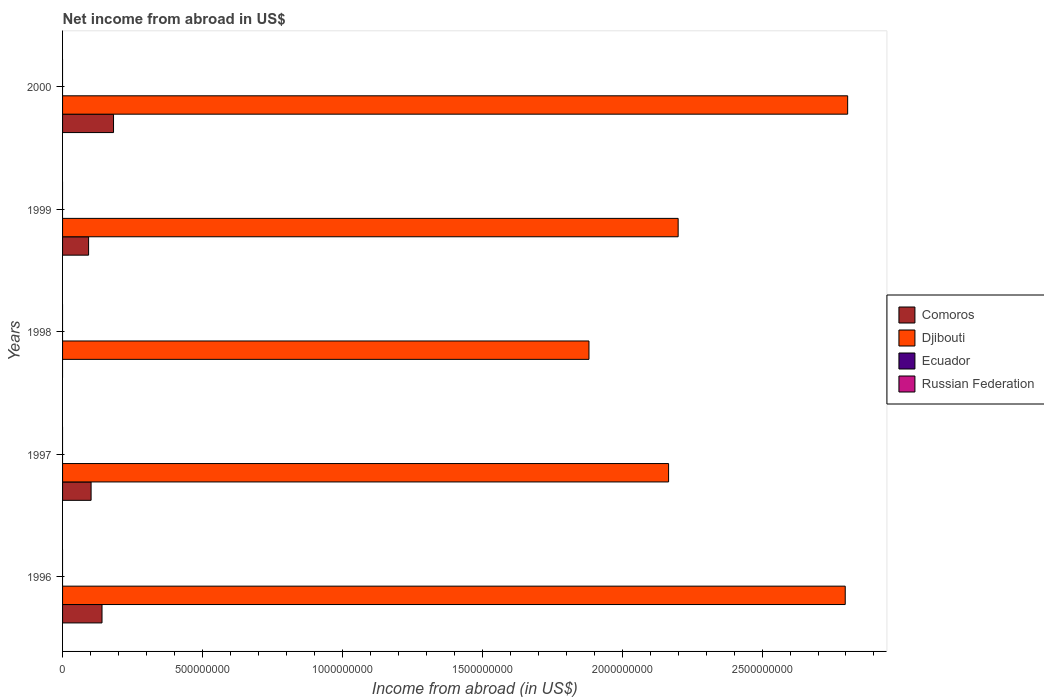How many different coloured bars are there?
Give a very brief answer. 2. Are the number of bars per tick equal to the number of legend labels?
Provide a short and direct response. No. Are the number of bars on each tick of the Y-axis equal?
Your response must be concise. No. How many bars are there on the 5th tick from the top?
Your response must be concise. 2. How many bars are there on the 4th tick from the bottom?
Your answer should be compact. 2. What is the label of the 1st group of bars from the top?
Offer a very short reply. 2000. Across all years, what is the maximum net income from abroad in Djibouti?
Your answer should be very brief. 2.81e+09. Across all years, what is the minimum net income from abroad in Djibouti?
Ensure brevity in your answer.  1.88e+09. In which year was the net income from abroad in Comoros maximum?
Give a very brief answer. 2000. What is the total net income from abroad in Ecuador in the graph?
Ensure brevity in your answer.  0. What is the difference between the net income from abroad in Comoros in 1997 and that in 2000?
Offer a very short reply. -8.02e+07. What is the difference between the net income from abroad in Djibouti in 1996 and the net income from abroad in Ecuador in 2000?
Offer a very short reply. 2.80e+09. What is the average net income from abroad in Comoros per year?
Offer a very short reply. 1.04e+08. In the year 1996, what is the difference between the net income from abroad in Djibouti and net income from abroad in Comoros?
Make the answer very short. 2.66e+09. In how many years, is the net income from abroad in Ecuador greater than 900000000 US$?
Your answer should be very brief. 0. What is the ratio of the net income from abroad in Comoros in 1997 to that in 1999?
Make the answer very short. 1.1. Is the net income from abroad in Comoros in 1997 less than that in 1999?
Provide a short and direct response. No. What is the difference between the highest and the second highest net income from abroad in Comoros?
Provide a succinct answer. 4.12e+07. What is the difference between the highest and the lowest net income from abroad in Comoros?
Ensure brevity in your answer.  1.82e+08. Is it the case that in every year, the sum of the net income from abroad in Russian Federation and net income from abroad in Ecuador is greater than the net income from abroad in Comoros?
Provide a succinct answer. No. How many years are there in the graph?
Give a very brief answer. 5. What is the difference between two consecutive major ticks on the X-axis?
Your answer should be compact. 5.00e+08. Does the graph contain grids?
Your answer should be very brief. No. How many legend labels are there?
Provide a succinct answer. 4. What is the title of the graph?
Your answer should be very brief. Net income from abroad in US$. Does "Albania" appear as one of the legend labels in the graph?
Give a very brief answer. No. What is the label or title of the X-axis?
Provide a short and direct response. Income from abroad (in US$). What is the label or title of the Y-axis?
Your answer should be very brief. Years. What is the Income from abroad (in US$) in Comoros in 1996?
Your answer should be compact. 1.41e+08. What is the Income from abroad (in US$) of Djibouti in 1996?
Give a very brief answer. 2.80e+09. What is the Income from abroad (in US$) of Comoros in 1997?
Provide a succinct answer. 1.02e+08. What is the Income from abroad (in US$) in Djibouti in 1997?
Your answer should be very brief. 2.17e+09. What is the Income from abroad (in US$) of Comoros in 1998?
Offer a very short reply. 0. What is the Income from abroad (in US$) of Djibouti in 1998?
Your answer should be compact. 1.88e+09. What is the Income from abroad (in US$) of Ecuador in 1998?
Provide a short and direct response. 0. What is the Income from abroad (in US$) in Russian Federation in 1998?
Offer a terse response. 0. What is the Income from abroad (in US$) in Comoros in 1999?
Your answer should be compact. 9.30e+07. What is the Income from abroad (in US$) of Djibouti in 1999?
Provide a succinct answer. 2.20e+09. What is the Income from abroad (in US$) in Ecuador in 1999?
Give a very brief answer. 0. What is the Income from abroad (in US$) of Russian Federation in 1999?
Offer a very short reply. 0. What is the Income from abroad (in US$) in Comoros in 2000?
Your response must be concise. 1.82e+08. What is the Income from abroad (in US$) of Djibouti in 2000?
Offer a very short reply. 2.81e+09. What is the Income from abroad (in US$) of Russian Federation in 2000?
Offer a very short reply. 0. Across all years, what is the maximum Income from abroad (in US$) of Comoros?
Give a very brief answer. 1.82e+08. Across all years, what is the maximum Income from abroad (in US$) in Djibouti?
Provide a short and direct response. 2.81e+09. Across all years, what is the minimum Income from abroad (in US$) of Comoros?
Offer a very short reply. 0. Across all years, what is the minimum Income from abroad (in US$) of Djibouti?
Keep it short and to the point. 1.88e+09. What is the total Income from abroad (in US$) of Comoros in the graph?
Provide a succinct answer. 5.18e+08. What is the total Income from abroad (in US$) of Djibouti in the graph?
Provide a succinct answer. 1.19e+1. What is the total Income from abroad (in US$) of Ecuador in the graph?
Offer a terse response. 0. What is the total Income from abroad (in US$) of Russian Federation in the graph?
Offer a terse response. 0. What is the difference between the Income from abroad (in US$) of Comoros in 1996 and that in 1997?
Make the answer very short. 3.90e+07. What is the difference between the Income from abroad (in US$) in Djibouti in 1996 and that in 1997?
Keep it short and to the point. 6.31e+08. What is the difference between the Income from abroad (in US$) of Djibouti in 1996 and that in 1998?
Offer a very short reply. 9.16e+08. What is the difference between the Income from abroad (in US$) in Comoros in 1996 and that in 1999?
Give a very brief answer. 4.80e+07. What is the difference between the Income from abroad (in US$) of Djibouti in 1996 and that in 1999?
Ensure brevity in your answer.  5.97e+08. What is the difference between the Income from abroad (in US$) in Comoros in 1996 and that in 2000?
Keep it short and to the point. -4.12e+07. What is the difference between the Income from abroad (in US$) of Djibouti in 1996 and that in 2000?
Ensure brevity in your answer.  -8.66e+06. What is the difference between the Income from abroad (in US$) of Djibouti in 1997 and that in 1998?
Your answer should be very brief. 2.85e+08. What is the difference between the Income from abroad (in US$) of Comoros in 1997 and that in 1999?
Offer a terse response. 8.99e+06. What is the difference between the Income from abroad (in US$) of Djibouti in 1997 and that in 1999?
Keep it short and to the point. -3.42e+07. What is the difference between the Income from abroad (in US$) of Comoros in 1997 and that in 2000?
Your answer should be compact. -8.02e+07. What is the difference between the Income from abroad (in US$) of Djibouti in 1997 and that in 2000?
Ensure brevity in your answer.  -6.40e+08. What is the difference between the Income from abroad (in US$) in Djibouti in 1998 and that in 1999?
Make the answer very short. -3.19e+08. What is the difference between the Income from abroad (in US$) of Djibouti in 1998 and that in 2000?
Your answer should be very brief. -9.25e+08. What is the difference between the Income from abroad (in US$) of Comoros in 1999 and that in 2000?
Provide a short and direct response. -8.92e+07. What is the difference between the Income from abroad (in US$) in Djibouti in 1999 and that in 2000?
Provide a short and direct response. -6.06e+08. What is the difference between the Income from abroad (in US$) of Comoros in 1996 and the Income from abroad (in US$) of Djibouti in 1997?
Keep it short and to the point. -2.03e+09. What is the difference between the Income from abroad (in US$) in Comoros in 1996 and the Income from abroad (in US$) in Djibouti in 1998?
Offer a terse response. -1.74e+09. What is the difference between the Income from abroad (in US$) of Comoros in 1996 and the Income from abroad (in US$) of Djibouti in 1999?
Your answer should be compact. -2.06e+09. What is the difference between the Income from abroad (in US$) in Comoros in 1996 and the Income from abroad (in US$) in Djibouti in 2000?
Give a very brief answer. -2.67e+09. What is the difference between the Income from abroad (in US$) in Comoros in 1997 and the Income from abroad (in US$) in Djibouti in 1998?
Your response must be concise. -1.78e+09. What is the difference between the Income from abroad (in US$) in Comoros in 1997 and the Income from abroad (in US$) in Djibouti in 1999?
Offer a very short reply. -2.10e+09. What is the difference between the Income from abroad (in US$) in Comoros in 1997 and the Income from abroad (in US$) in Djibouti in 2000?
Keep it short and to the point. -2.70e+09. What is the difference between the Income from abroad (in US$) in Comoros in 1999 and the Income from abroad (in US$) in Djibouti in 2000?
Your answer should be compact. -2.71e+09. What is the average Income from abroad (in US$) in Comoros per year?
Make the answer very short. 1.04e+08. What is the average Income from abroad (in US$) of Djibouti per year?
Keep it short and to the point. 2.37e+09. What is the average Income from abroad (in US$) in Ecuador per year?
Your answer should be very brief. 0. In the year 1996, what is the difference between the Income from abroad (in US$) of Comoros and Income from abroad (in US$) of Djibouti?
Your response must be concise. -2.66e+09. In the year 1997, what is the difference between the Income from abroad (in US$) of Comoros and Income from abroad (in US$) of Djibouti?
Ensure brevity in your answer.  -2.06e+09. In the year 1999, what is the difference between the Income from abroad (in US$) in Comoros and Income from abroad (in US$) in Djibouti?
Your response must be concise. -2.11e+09. In the year 2000, what is the difference between the Income from abroad (in US$) of Comoros and Income from abroad (in US$) of Djibouti?
Give a very brief answer. -2.62e+09. What is the ratio of the Income from abroad (in US$) of Comoros in 1996 to that in 1997?
Offer a very short reply. 1.38. What is the ratio of the Income from abroad (in US$) in Djibouti in 1996 to that in 1997?
Your answer should be very brief. 1.29. What is the ratio of the Income from abroad (in US$) of Djibouti in 1996 to that in 1998?
Offer a very short reply. 1.49. What is the ratio of the Income from abroad (in US$) of Comoros in 1996 to that in 1999?
Your answer should be compact. 1.52. What is the ratio of the Income from abroad (in US$) of Djibouti in 1996 to that in 1999?
Make the answer very short. 1.27. What is the ratio of the Income from abroad (in US$) of Comoros in 1996 to that in 2000?
Keep it short and to the point. 0.77. What is the ratio of the Income from abroad (in US$) of Djibouti in 1997 to that in 1998?
Your answer should be compact. 1.15. What is the ratio of the Income from abroad (in US$) of Comoros in 1997 to that in 1999?
Make the answer very short. 1.1. What is the ratio of the Income from abroad (in US$) of Djibouti in 1997 to that in 1999?
Make the answer very short. 0.98. What is the ratio of the Income from abroad (in US$) in Comoros in 1997 to that in 2000?
Your answer should be compact. 0.56. What is the ratio of the Income from abroad (in US$) of Djibouti in 1997 to that in 2000?
Provide a short and direct response. 0.77. What is the ratio of the Income from abroad (in US$) of Djibouti in 1998 to that in 1999?
Your answer should be very brief. 0.86. What is the ratio of the Income from abroad (in US$) of Djibouti in 1998 to that in 2000?
Ensure brevity in your answer.  0.67. What is the ratio of the Income from abroad (in US$) in Comoros in 1999 to that in 2000?
Offer a very short reply. 0.51. What is the ratio of the Income from abroad (in US$) of Djibouti in 1999 to that in 2000?
Offer a terse response. 0.78. What is the difference between the highest and the second highest Income from abroad (in US$) in Comoros?
Provide a short and direct response. 4.12e+07. What is the difference between the highest and the second highest Income from abroad (in US$) of Djibouti?
Give a very brief answer. 8.66e+06. What is the difference between the highest and the lowest Income from abroad (in US$) of Comoros?
Offer a terse response. 1.82e+08. What is the difference between the highest and the lowest Income from abroad (in US$) of Djibouti?
Your answer should be compact. 9.25e+08. 